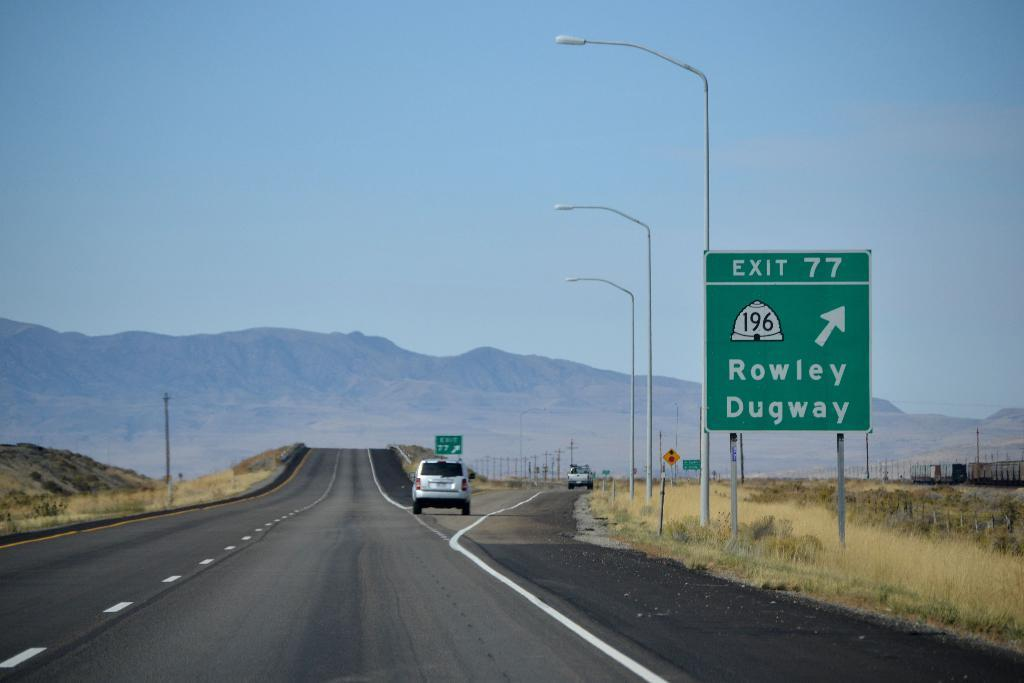Provide a one-sentence caption for the provided image. A road with mountain in the backyard and a sign for exit 77 Rowley and Dugway. 